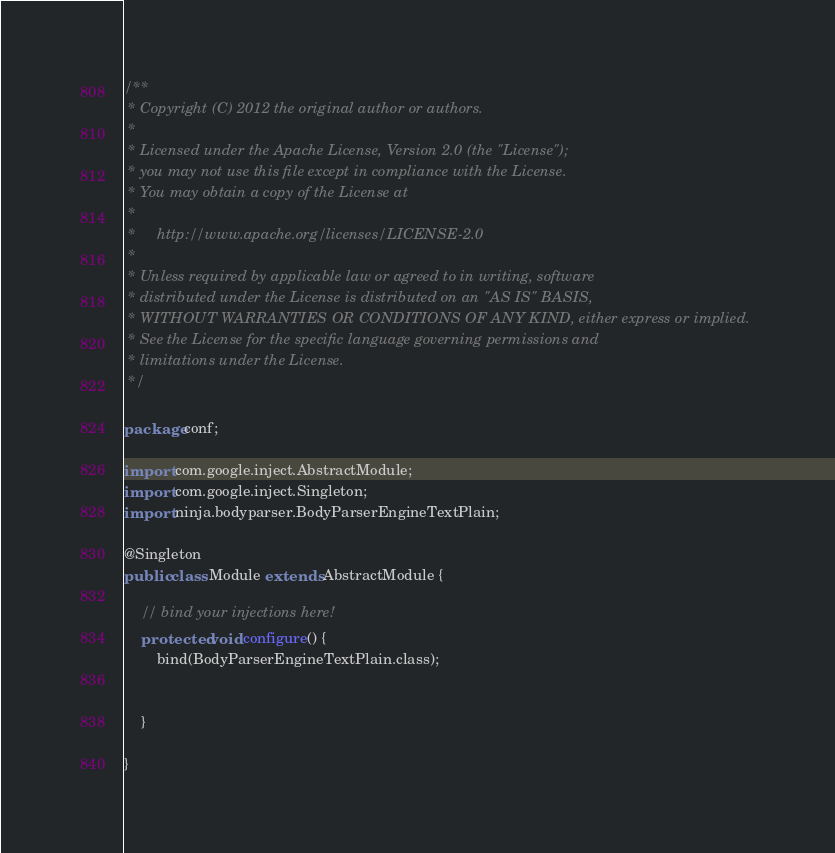<code> <loc_0><loc_0><loc_500><loc_500><_Java_>/**
 * Copyright (C) 2012 the original author or authors.
 *
 * Licensed under the Apache License, Version 2.0 (the "License");
 * you may not use this file except in compliance with the License.
 * You may obtain a copy of the License at
 *
 *     http://www.apache.org/licenses/LICENSE-2.0
 *
 * Unless required by applicable law or agreed to in writing, software
 * distributed under the License is distributed on an "AS IS" BASIS,
 * WITHOUT WARRANTIES OR CONDITIONS OF ANY KIND, either express or implied.
 * See the License for the specific language governing permissions and
 * limitations under the License.
 */

package conf;

import com.google.inject.AbstractModule;
import com.google.inject.Singleton;
import ninja.bodyparser.BodyParserEngineTextPlain;

@Singleton
public class Module extends AbstractModule {

    // bind your injections here!
    protected void configure() {
        bind(BodyParserEngineTextPlain.class);

        
    }

}
</code> 